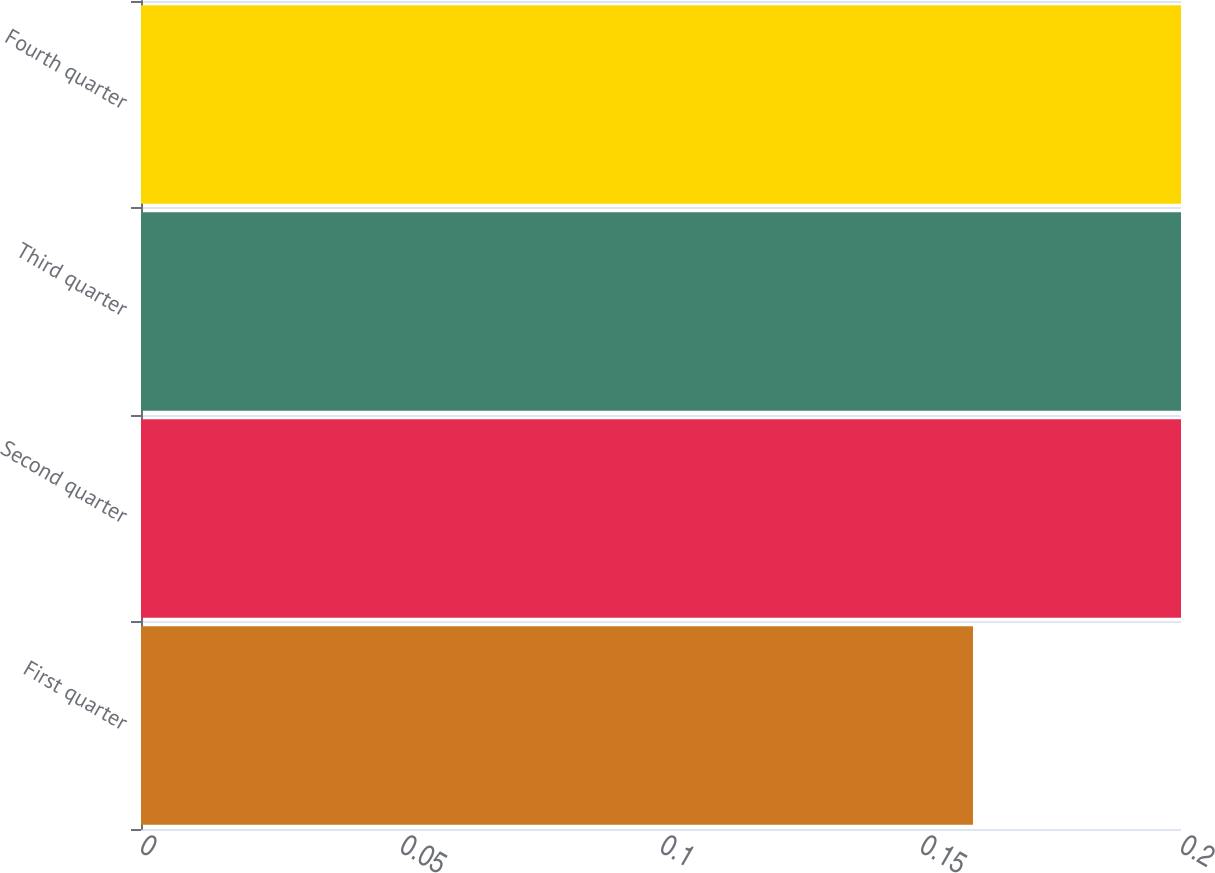<chart> <loc_0><loc_0><loc_500><loc_500><bar_chart><fcel>First quarter<fcel>Second quarter<fcel>Third quarter<fcel>Fourth quarter<nl><fcel>0.16<fcel>0.2<fcel>0.2<fcel>0.2<nl></chart> 